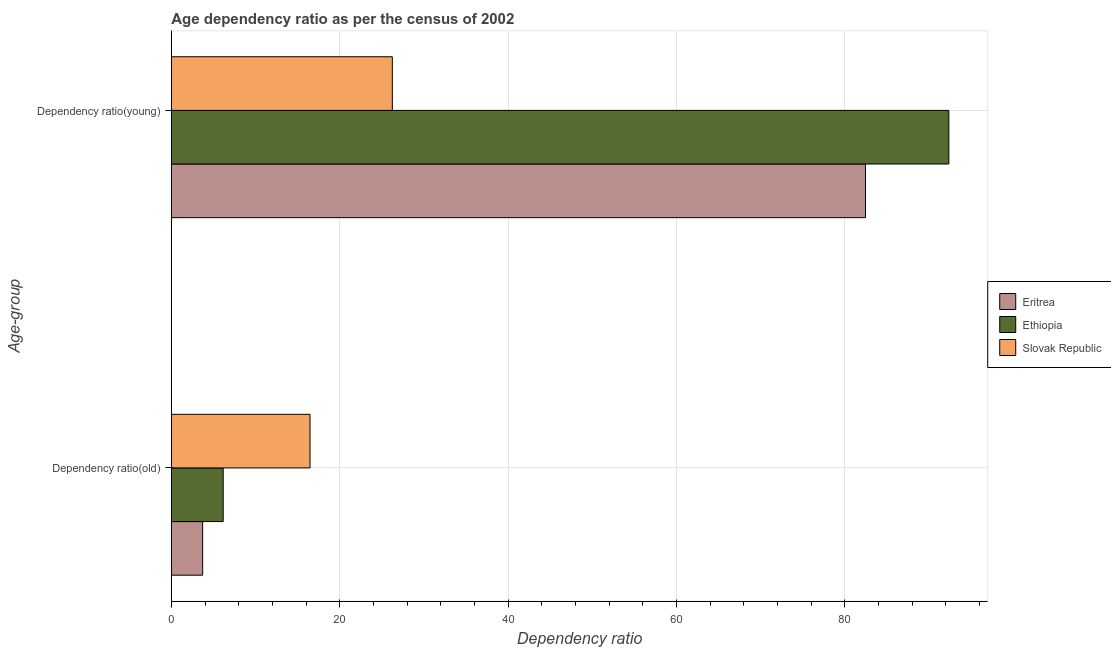How many different coloured bars are there?
Provide a succinct answer. 3. Are the number of bars per tick equal to the number of legend labels?
Ensure brevity in your answer.  Yes. How many bars are there on the 1st tick from the bottom?
Offer a very short reply. 3. What is the label of the 1st group of bars from the top?
Make the answer very short. Dependency ratio(young). What is the age dependency ratio(young) in Ethiopia?
Provide a short and direct response. 92.36. Across all countries, what is the maximum age dependency ratio(old)?
Keep it short and to the point. 16.47. Across all countries, what is the minimum age dependency ratio(young)?
Offer a very short reply. 26.25. In which country was the age dependency ratio(old) maximum?
Provide a succinct answer. Slovak Republic. In which country was the age dependency ratio(old) minimum?
Give a very brief answer. Eritrea. What is the total age dependency ratio(young) in the graph?
Offer a terse response. 201.08. What is the difference between the age dependency ratio(young) in Ethiopia and that in Eritrea?
Make the answer very short. 9.9. What is the difference between the age dependency ratio(young) in Slovak Republic and the age dependency ratio(old) in Eritrea?
Your answer should be compact. 22.53. What is the average age dependency ratio(old) per country?
Keep it short and to the point. 8.78. What is the difference between the age dependency ratio(old) and age dependency ratio(young) in Slovak Republic?
Offer a terse response. -9.78. In how many countries, is the age dependency ratio(old) greater than 72 ?
Keep it short and to the point. 0. What is the ratio of the age dependency ratio(old) in Eritrea to that in Ethiopia?
Give a very brief answer. 0.6. What does the 2nd bar from the top in Dependency ratio(old) represents?
Keep it short and to the point. Ethiopia. What does the 2nd bar from the bottom in Dependency ratio(old) represents?
Make the answer very short. Ethiopia. Are all the bars in the graph horizontal?
Keep it short and to the point. Yes. Are the values on the major ticks of X-axis written in scientific E-notation?
Give a very brief answer. No. Where does the legend appear in the graph?
Provide a short and direct response. Center right. How many legend labels are there?
Provide a short and direct response. 3. What is the title of the graph?
Give a very brief answer. Age dependency ratio as per the census of 2002. Does "Tunisia" appear as one of the legend labels in the graph?
Your answer should be compact. No. What is the label or title of the X-axis?
Keep it short and to the point. Dependency ratio. What is the label or title of the Y-axis?
Provide a succinct answer. Age-group. What is the Dependency ratio in Eritrea in Dependency ratio(old)?
Provide a succinct answer. 3.72. What is the Dependency ratio of Ethiopia in Dependency ratio(old)?
Offer a very short reply. 6.15. What is the Dependency ratio in Slovak Republic in Dependency ratio(old)?
Your answer should be compact. 16.47. What is the Dependency ratio in Eritrea in Dependency ratio(young)?
Give a very brief answer. 82.46. What is the Dependency ratio in Ethiopia in Dependency ratio(young)?
Your answer should be very brief. 92.36. What is the Dependency ratio of Slovak Republic in Dependency ratio(young)?
Your answer should be compact. 26.25. Across all Age-group, what is the maximum Dependency ratio in Eritrea?
Ensure brevity in your answer.  82.46. Across all Age-group, what is the maximum Dependency ratio in Ethiopia?
Keep it short and to the point. 92.36. Across all Age-group, what is the maximum Dependency ratio of Slovak Republic?
Your answer should be very brief. 26.25. Across all Age-group, what is the minimum Dependency ratio of Eritrea?
Your answer should be compact. 3.72. Across all Age-group, what is the minimum Dependency ratio in Ethiopia?
Your response must be concise. 6.15. Across all Age-group, what is the minimum Dependency ratio of Slovak Republic?
Ensure brevity in your answer.  16.47. What is the total Dependency ratio in Eritrea in the graph?
Your answer should be very brief. 86.18. What is the total Dependency ratio of Ethiopia in the graph?
Provide a short and direct response. 98.52. What is the total Dependency ratio in Slovak Republic in the graph?
Provide a short and direct response. 42.72. What is the difference between the Dependency ratio in Eritrea in Dependency ratio(old) and that in Dependency ratio(young)?
Your answer should be very brief. -78.75. What is the difference between the Dependency ratio in Ethiopia in Dependency ratio(old) and that in Dependency ratio(young)?
Ensure brevity in your answer.  -86.21. What is the difference between the Dependency ratio in Slovak Republic in Dependency ratio(old) and that in Dependency ratio(young)?
Make the answer very short. -9.78. What is the difference between the Dependency ratio of Eritrea in Dependency ratio(old) and the Dependency ratio of Ethiopia in Dependency ratio(young)?
Your response must be concise. -88.65. What is the difference between the Dependency ratio in Eritrea in Dependency ratio(old) and the Dependency ratio in Slovak Republic in Dependency ratio(young)?
Keep it short and to the point. -22.53. What is the difference between the Dependency ratio in Ethiopia in Dependency ratio(old) and the Dependency ratio in Slovak Republic in Dependency ratio(young)?
Offer a very short reply. -20.1. What is the average Dependency ratio of Eritrea per Age-group?
Your answer should be very brief. 43.09. What is the average Dependency ratio of Ethiopia per Age-group?
Provide a short and direct response. 49.26. What is the average Dependency ratio in Slovak Republic per Age-group?
Offer a terse response. 21.36. What is the difference between the Dependency ratio of Eritrea and Dependency ratio of Ethiopia in Dependency ratio(old)?
Your answer should be very brief. -2.44. What is the difference between the Dependency ratio in Eritrea and Dependency ratio in Slovak Republic in Dependency ratio(old)?
Offer a terse response. -12.76. What is the difference between the Dependency ratio of Ethiopia and Dependency ratio of Slovak Republic in Dependency ratio(old)?
Offer a very short reply. -10.32. What is the difference between the Dependency ratio of Eritrea and Dependency ratio of Ethiopia in Dependency ratio(young)?
Your answer should be very brief. -9.9. What is the difference between the Dependency ratio of Eritrea and Dependency ratio of Slovak Republic in Dependency ratio(young)?
Provide a succinct answer. 56.21. What is the difference between the Dependency ratio in Ethiopia and Dependency ratio in Slovak Republic in Dependency ratio(young)?
Your response must be concise. 66.11. What is the ratio of the Dependency ratio of Eritrea in Dependency ratio(old) to that in Dependency ratio(young)?
Provide a short and direct response. 0.05. What is the ratio of the Dependency ratio of Ethiopia in Dependency ratio(old) to that in Dependency ratio(young)?
Provide a short and direct response. 0.07. What is the ratio of the Dependency ratio of Slovak Republic in Dependency ratio(old) to that in Dependency ratio(young)?
Your answer should be very brief. 0.63. What is the difference between the highest and the second highest Dependency ratio in Eritrea?
Keep it short and to the point. 78.75. What is the difference between the highest and the second highest Dependency ratio of Ethiopia?
Give a very brief answer. 86.21. What is the difference between the highest and the second highest Dependency ratio of Slovak Republic?
Your answer should be very brief. 9.78. What is the difference between the highest and the lowest Dependency ratio in Eritrea?
Offer a terse response. 78.75. What is the difference between the highest and the lowest Dependency ratio of Ethiopia?
Your response must be concise. 86.21. What is the difference between the highest and the lowest Dependency ratio of Slovak Republic?
Your response must be concise. 9.78. 